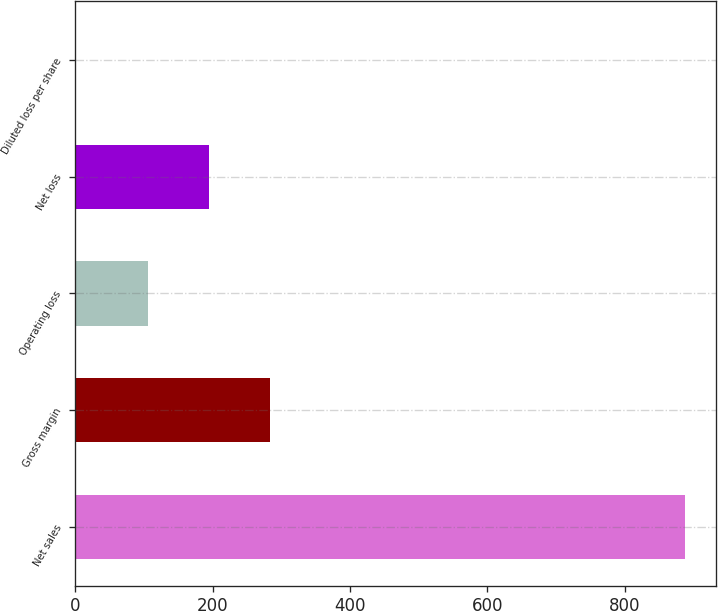Convert chart. <chart><loc_0><loc_0><loc_500><loc_500><bar_chart><fcel>Net sales<fcel>Gross margin<fcel>Operating loss<fcel>Net loss<fcel>Diluted loss per share<nl><fcel>888.5<fcel>283.26<fcel>105.6<fcel>194.43<fcel>0.2<nl></chart> 